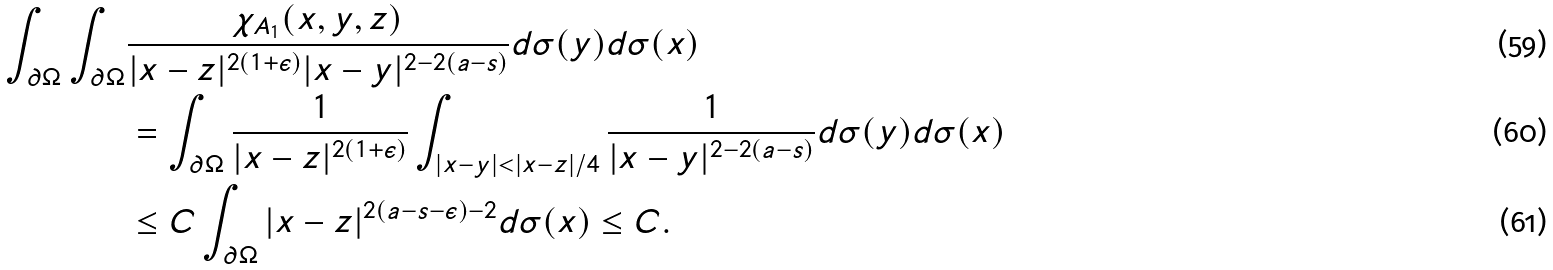<formula> <loc_0><loc_0><loc_500><loc_500>\int _ { \partial \Omega } \int _ { \partial \Omega } & \frac { \chi _ { A _ { 1 } } ( x , y , z ) } { | x - z | ^ { 2 ( 1 + \epsilon ) } | x - y | ^ { 2 - 2 ( a - s ) } } d \sigma ( y ) d \sigma ( x ) \\ & = \int _ { \partial \Omega } \frac { 1 } { | x - z | ^ { 2 ( 1 + \epsilon ) } } \int _ { | x - y | < | x - z | / 4 } \frac { 1 } { | x - y | ^ { 2 - 2 ( a - s ) } } d \sigma ( y ) d \sigma ( x ) \\ & \leq C \int _ { \partial \Omega } | x - z | ^ { 2 ( a - s - \epsilon ) - 2 } d \sigma ( x ) \leq C .</formula> 